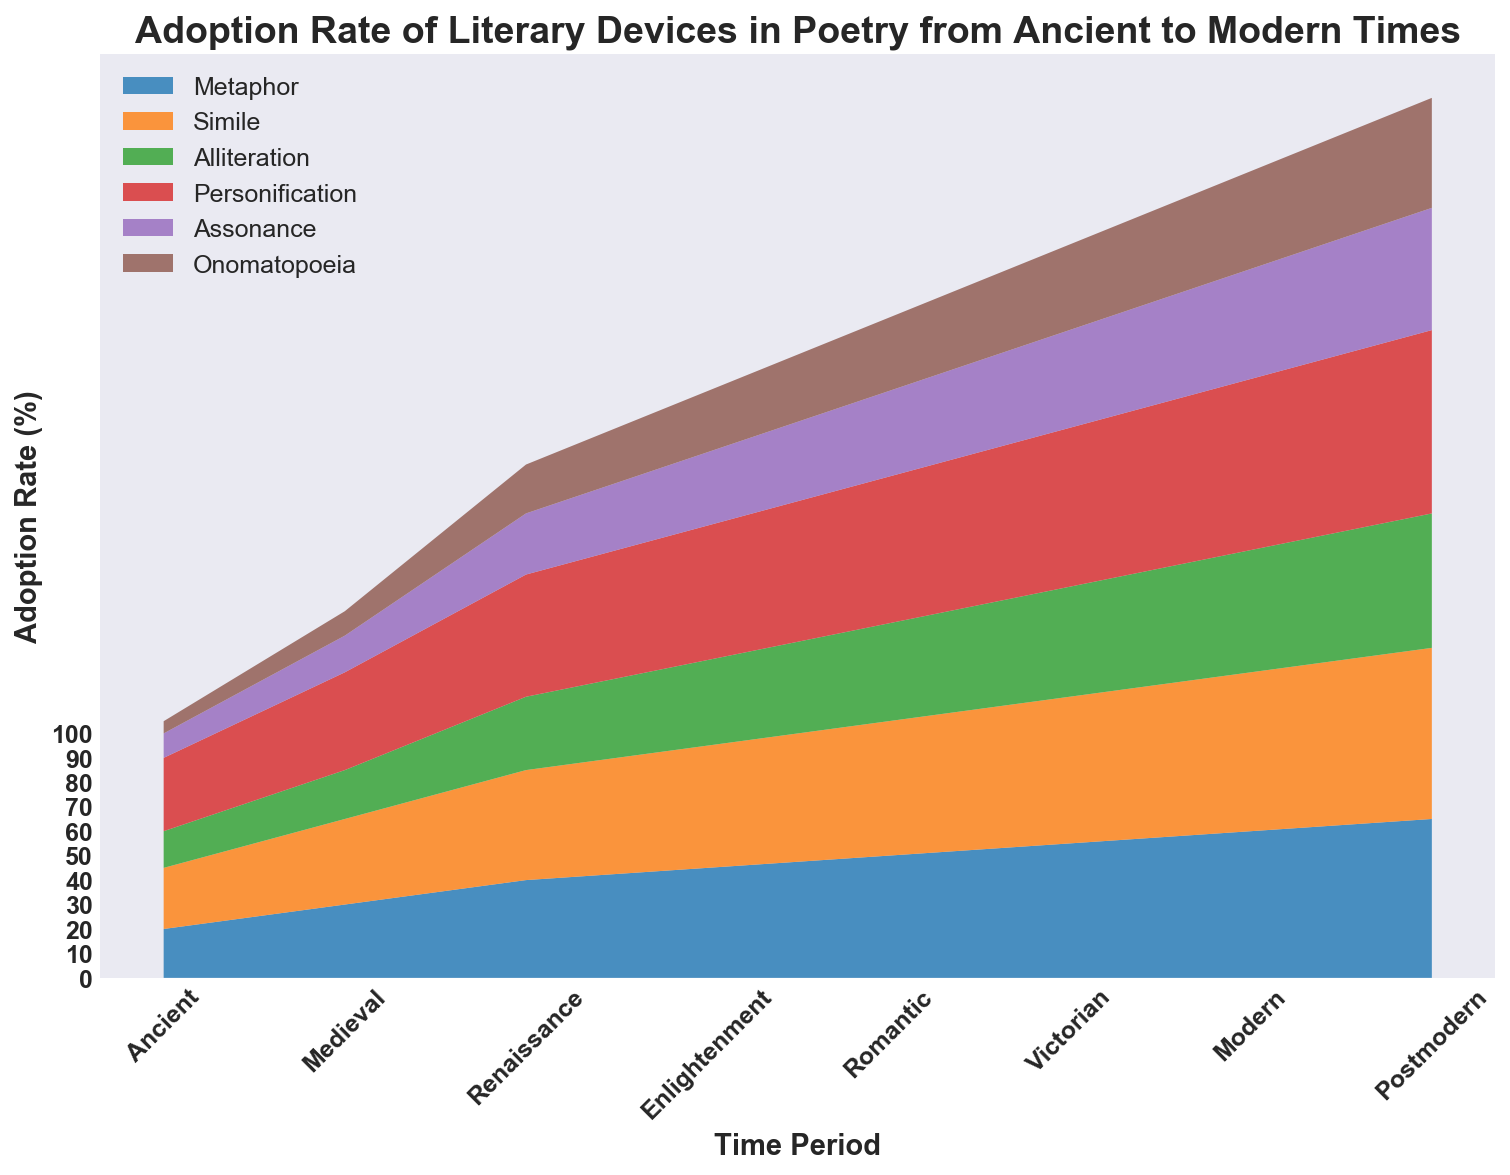Which time period saw the highest adoption rate of personification? Observing the area chart, the highest point for personification is reached in the Postmodern period, indicated by the peak at 75%.
Answer: Postmodern In which time period is the adoption rate of alliteration higher than that of metaphor? By comparing the alliteration and metaphor areas, we see the only period where alliteration exceeds metaphor is the Enlightenment period, with alliteration at 35% vs metaphor at 45%.
Answer: None What is the approximate difference in adoption rate of simile between the Victorian and Medieval periods? From the chart, simile in the Victorian period is roughly at 60%, and in the Medieval period, it's about 35%. The difference is 60% - 35% = 25%.
Answer: 25% Which two literary devices have the same adoption rate in the Ancient period and what is that rate? From the chart, in the Ancient period, metaphor has a 20% adoption rate, and assonance has a 10% adoption rate.
Answer: None have the same rate Which literary device shows the most significant increase in adoption rate from the Romantic to the Postmodern period? Comparing the adoption rates at Romantic (60%) and Postmodern (75%), personification shows the largest increase of 75% - 60% = 15%.
Answer: Personification During the Renaissance period, which literary device has the lowest adoption rate? From the chart, during the Renaissance period, the lowest adoption rate among the devices is onomatopoeia at 20%.
Answer: Onomatopoeia Is the adoption rate of metaphor in the Modern period higher than the adoption rate of alliteration in the Victorian period? From the chart, metaphor in the Modern period is at 60%, while alliteration in the Victorian period is at 45%, making the metaphoric adoption rate higher.
Answer: Yes How did the adoption rate of assonance change from the Medieval to the Victorian period? The chart shows assonance's adoption rate increasing from Medieval (15%) to Victorian (40%).
Answer: Increased by 25% On comparing the Enlightenment and Romantic periods, which literary device saw a decrease in its adoption rate, if any? Reviewing the data, none of the literary devices show a decreased rate from the Enlightenment to Romantic periods; all increase.
Answer: None What is the combined adoption rate of simile and personification in the Victorian period? Simile in the Victorian period is 60% and personification is 65%. The combined rate is 60% + 65% = 125%.
Answer: 125% 